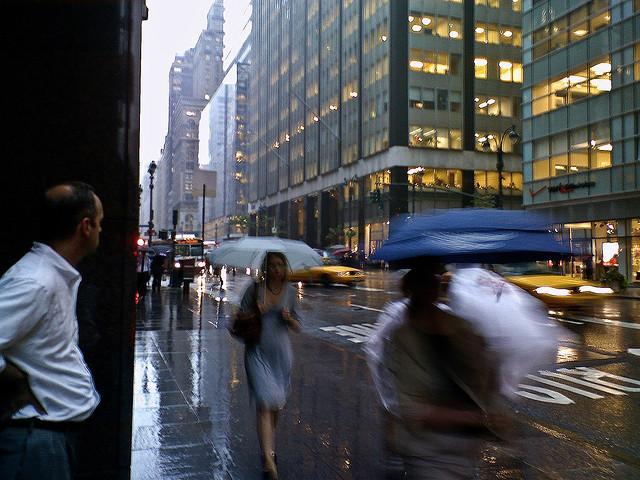What is the man wearing white shirt waiting for? Please explain your reasoning. rain stopping. The man is waiting under a roof so he doesn't get wet. 